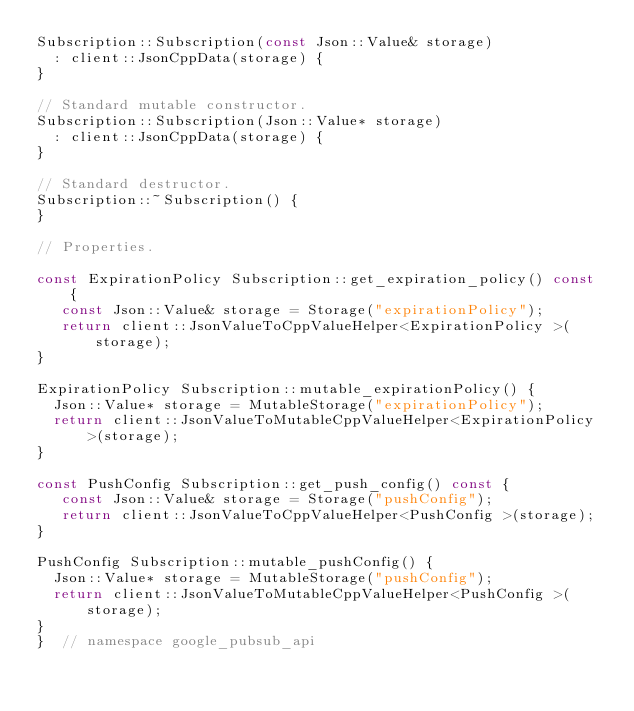<code> <loc_0><loc_0><loc_500><loc_500><_C++_>Subscription::Subscription(const Json::Value& storage)
  : client::JsonCppData(storage) {
}

// Standard mutable constructor.
Subscription::Subscription(Json::Value* storage)
  : client::JsonCppData(storage) {
}

// Standard destructor.
Subscription::~Subscription() {
}

// Properties.

const ExpirationPolicy Subscription::get_expiration_policy() const {
   const Json::Value& storage = Storage("expirationPolicy");
   return client::JsonValueToCppValueHelper<ExpirationPolicy >(storage);
}

ExpirationPolicy Subscription::mutable_expirationPolicy() {
  Json::Value* storage = MutableStorage("expirationPolicy");
  return client::JsonValueToMutableCppValueHelper<ExpirationPolicy >(storage);
}

const PushConfig Subscription::get_push_config() const {
   const Json::Value& storage = Storage("pushConfig");
   return client::JsonValueToCppValueHelper<PushConfig >(storage);
}

PushConfig Subscription::mutable_pushConfig() {
  Json::Value* storage = MutableStorage("pushConfig");
  return client::JsonValueToMutableCppValueHelper<PushConfig >(storage);
}
}  // namespace google_pubsub_api
</code> 